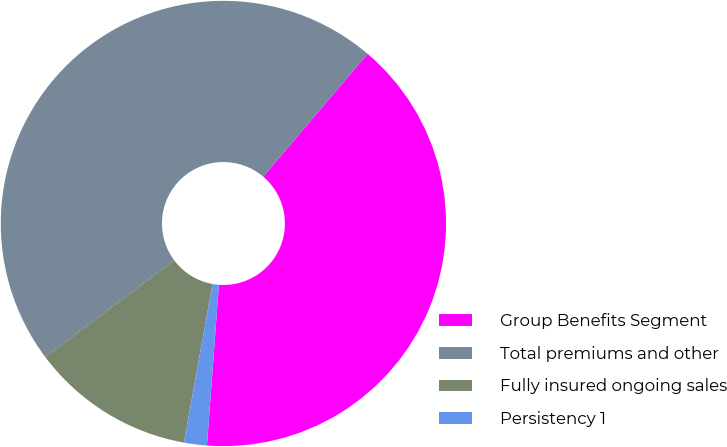Convert chart to OTSL. <chart><loc_0><loc_0><loc_500><loc_500><pie_chart><fcel>Group Benefits Segment<fcel>Total premiums and other<fcel>Fully insured ongoing sales<fcel>Persistency 1<nl><fcel>39.97%<fcel>46.46%<fcel>11.92%<fcel>1.66%<nl></chart> 